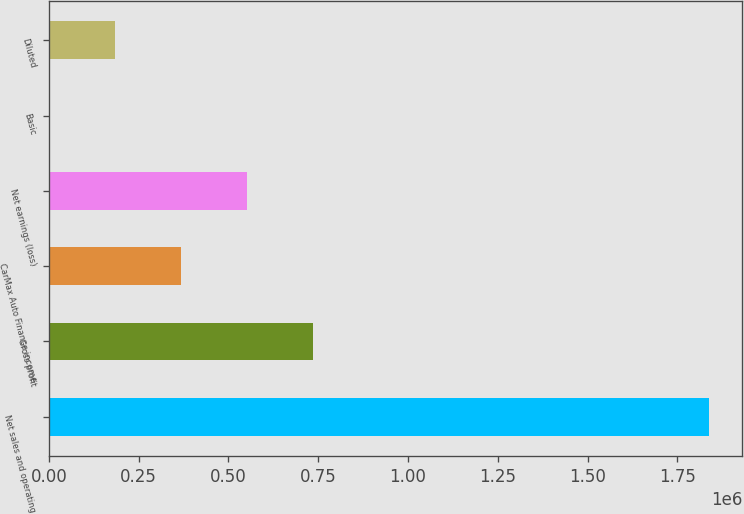<chart> <loc_0><loc_0><loc_500><loc_500><bar_chart><fcel>Net sales and operating<fcel>Gross profit<fcel>CarMax Auto Finance income<fcel>Net earnings (loss)<fcel>Basic<fcel>Diluted<nl><fcel>1.83905e+06<fcel>735622<fcel>367811<fcel>551716<fcel>0.06<fcel>183905<nl></chart> 